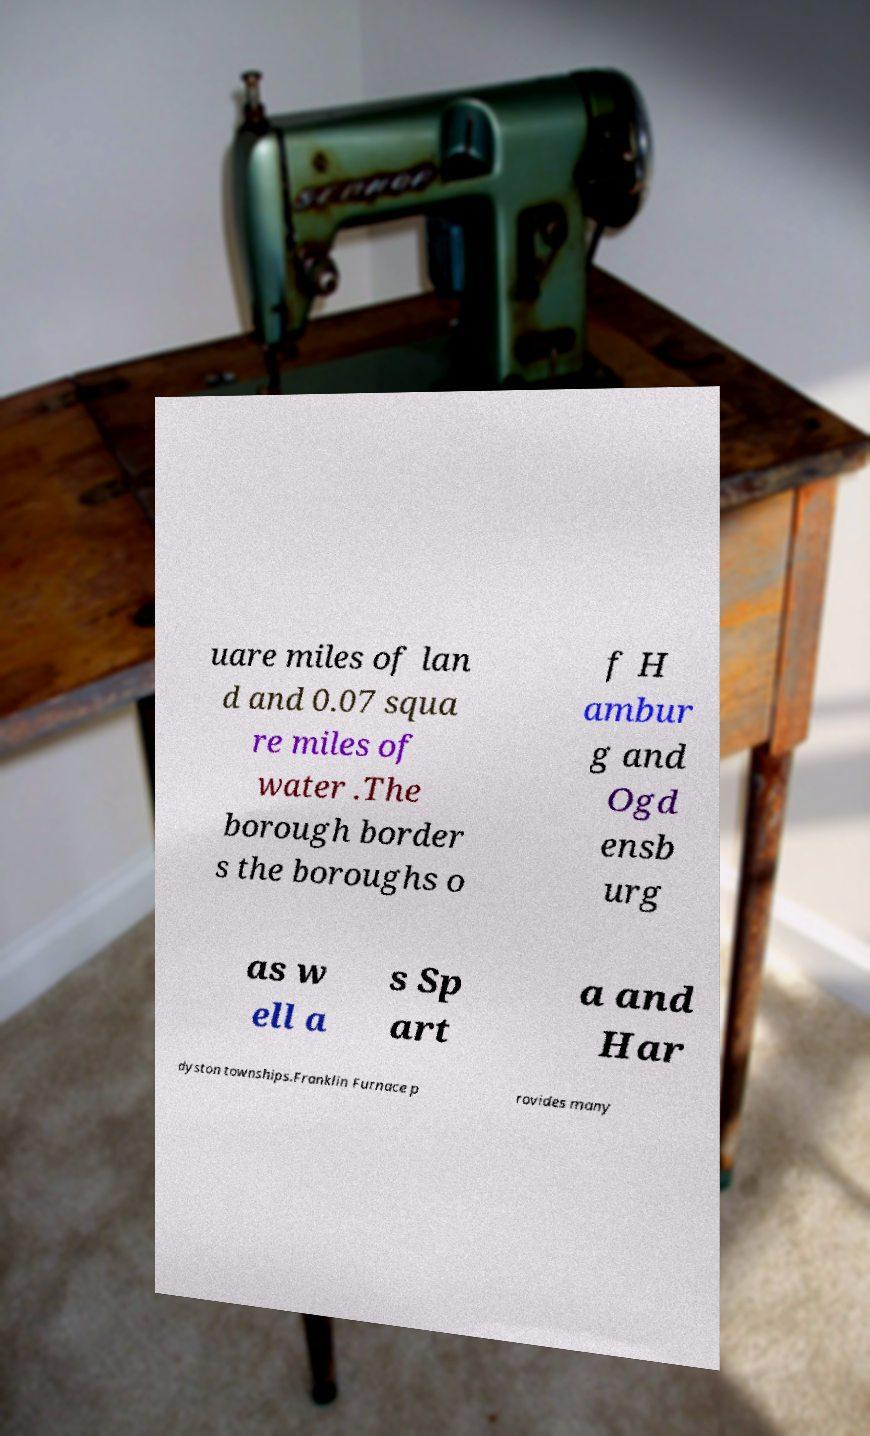I need the written content from this picture converted into text. Can you do that? uare miles of lan d and 0.07 squa re miles of water .The borough border s the boroughs o f H ambur g and Ogd ensb urg as w ell a s Sp art a and Har dyston townships.Franklin Furnace p rovides many 